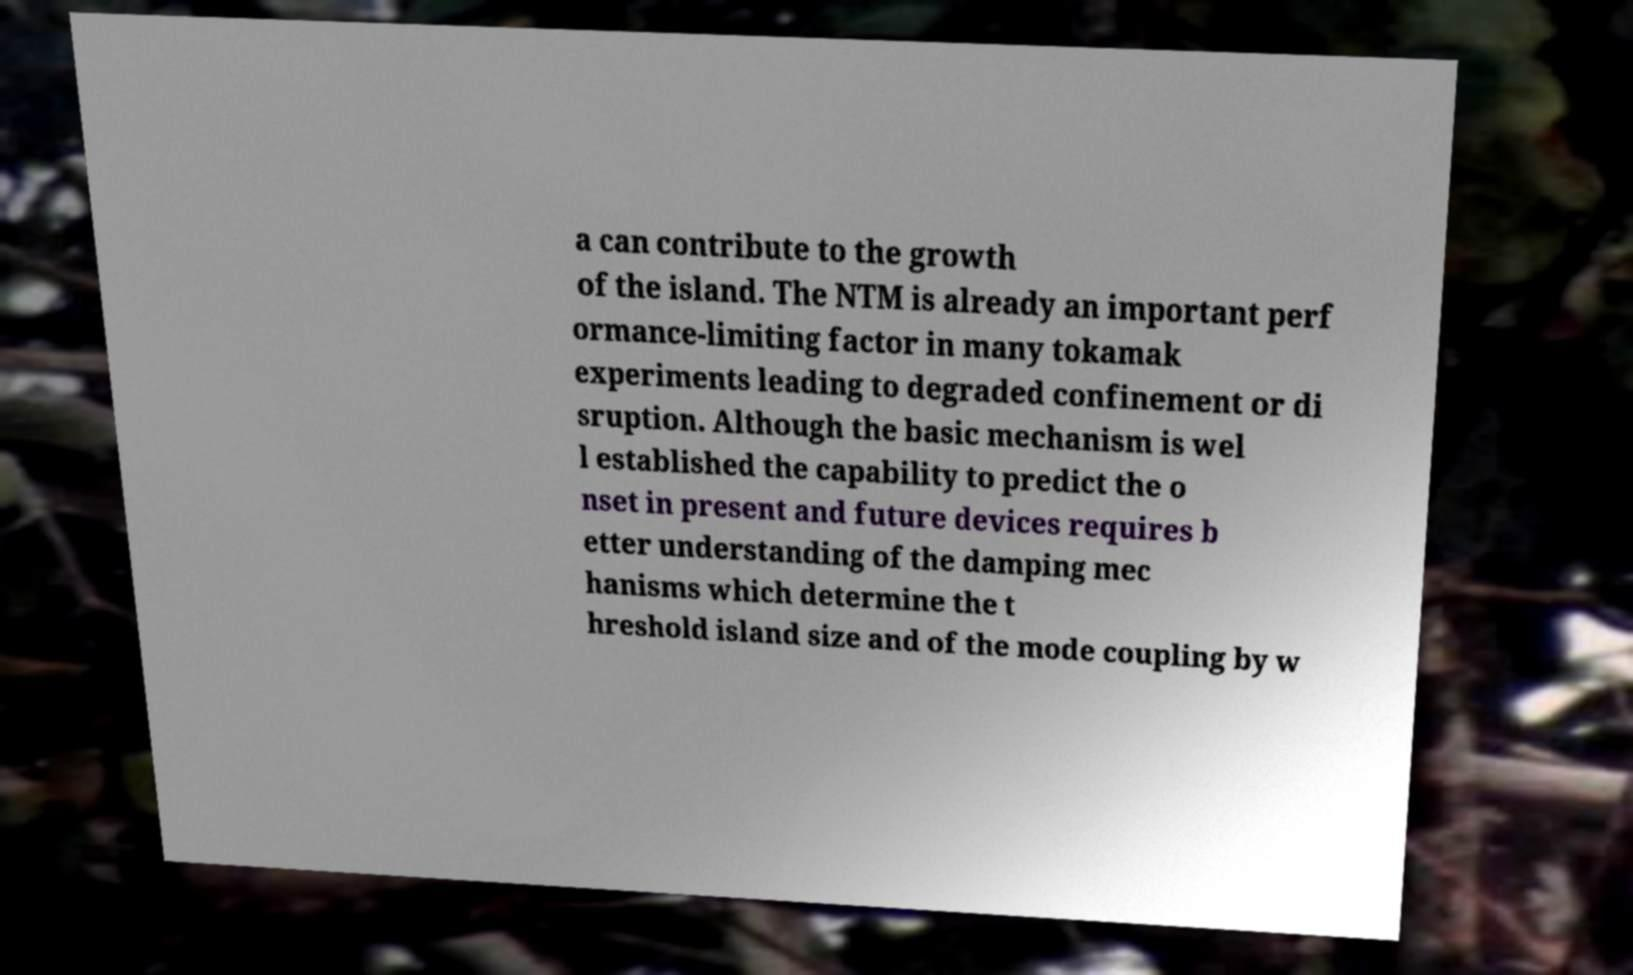There's text embedded in this image that I need extracted. Can you transcribe it verbatim? a can contribute to the growth of the island. The NTM is already an important perf ormance-limiting factor in many tokamak experiments leading to degraded confinement or di sruption. Although the basic mechanism is wel l established the capability to predict the o nset in present and future devices requires b etter understanding of the damping mec hanisms which determine the t hreshold island size and of the mode coupling by w 